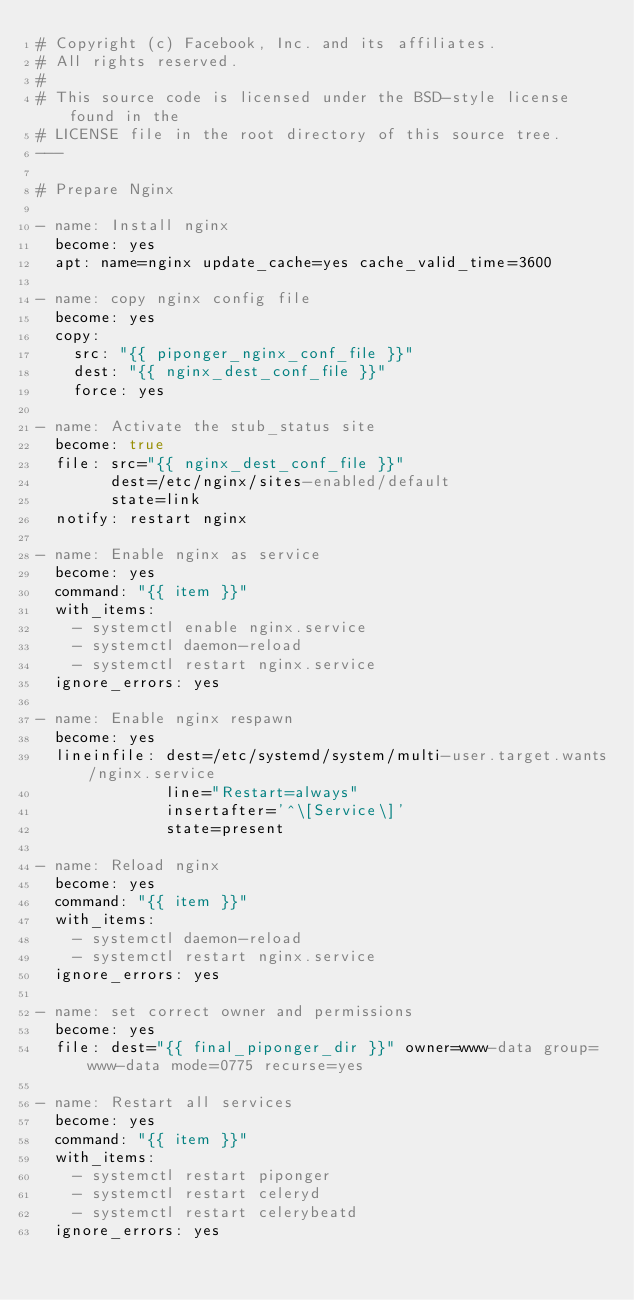Convert code to text. <code><loc_0><loc_0><loc_500><loc_500><_YAML_># Copyright (c) Facebook, Inc. and its affiliates.
# All rights reserved.
#
# This source code is licensed under the BSD-style license found in the
# LICENSE file in the root directory of this source tree.
---

# Prepare Nginx

- name: Install nginx
  become: yes
  apt: name=nginx update_cache=yes cache_valid_time=3600

- name: copy nginx config file
  become: yes
  copy:
    src: "{{ piponger_nginx_conf_file }}"
    dest: "{{ nginx_dest_conf_file }}"
    force: yes

- name: Activate the stub_status site
  become: true
  file: src="{{ nginx_dest_conf_file }}"
        dest=/etc/nginx/sites-enabled/default
        state=link
  notify: restart nginx

- name: Enable nginx as service
  become: yes
  command: "{{ item }}"
  with_items:
    - systemctl enable nginx.service
    - systemctl daemon-reload
    - systemctl restart nginx.service
  ignore_errors: yes

- name: Enable nginx respawn
  become: yes
  lineinfile: dest=/etc/systemd/system/multi-user.target.wants/nginx.service
              line="Restart=always"
              insertafter='^\[Service\]'
              state=present

- name: Reload nginx
  become: yes
  command: "{{ item }}"
  with_items:
    - systemctl daemon-reload
    - systemctl restart nginx.service
  ignore_errors: yes

- name: set correct owner and permissions
  become: yes
  file: dest="{{ final_piponger_dir }}" owner=www-data group=www-data mode=0775 recurse=yes

- name: Restart all services
  become: yes
  command: "{{ item }}"
  with_items:
    - systemctl restart piponger
    - systemctl restart celeryd
    - systemctl restart celerybeatd
  ignore_errors: yes
</code> 